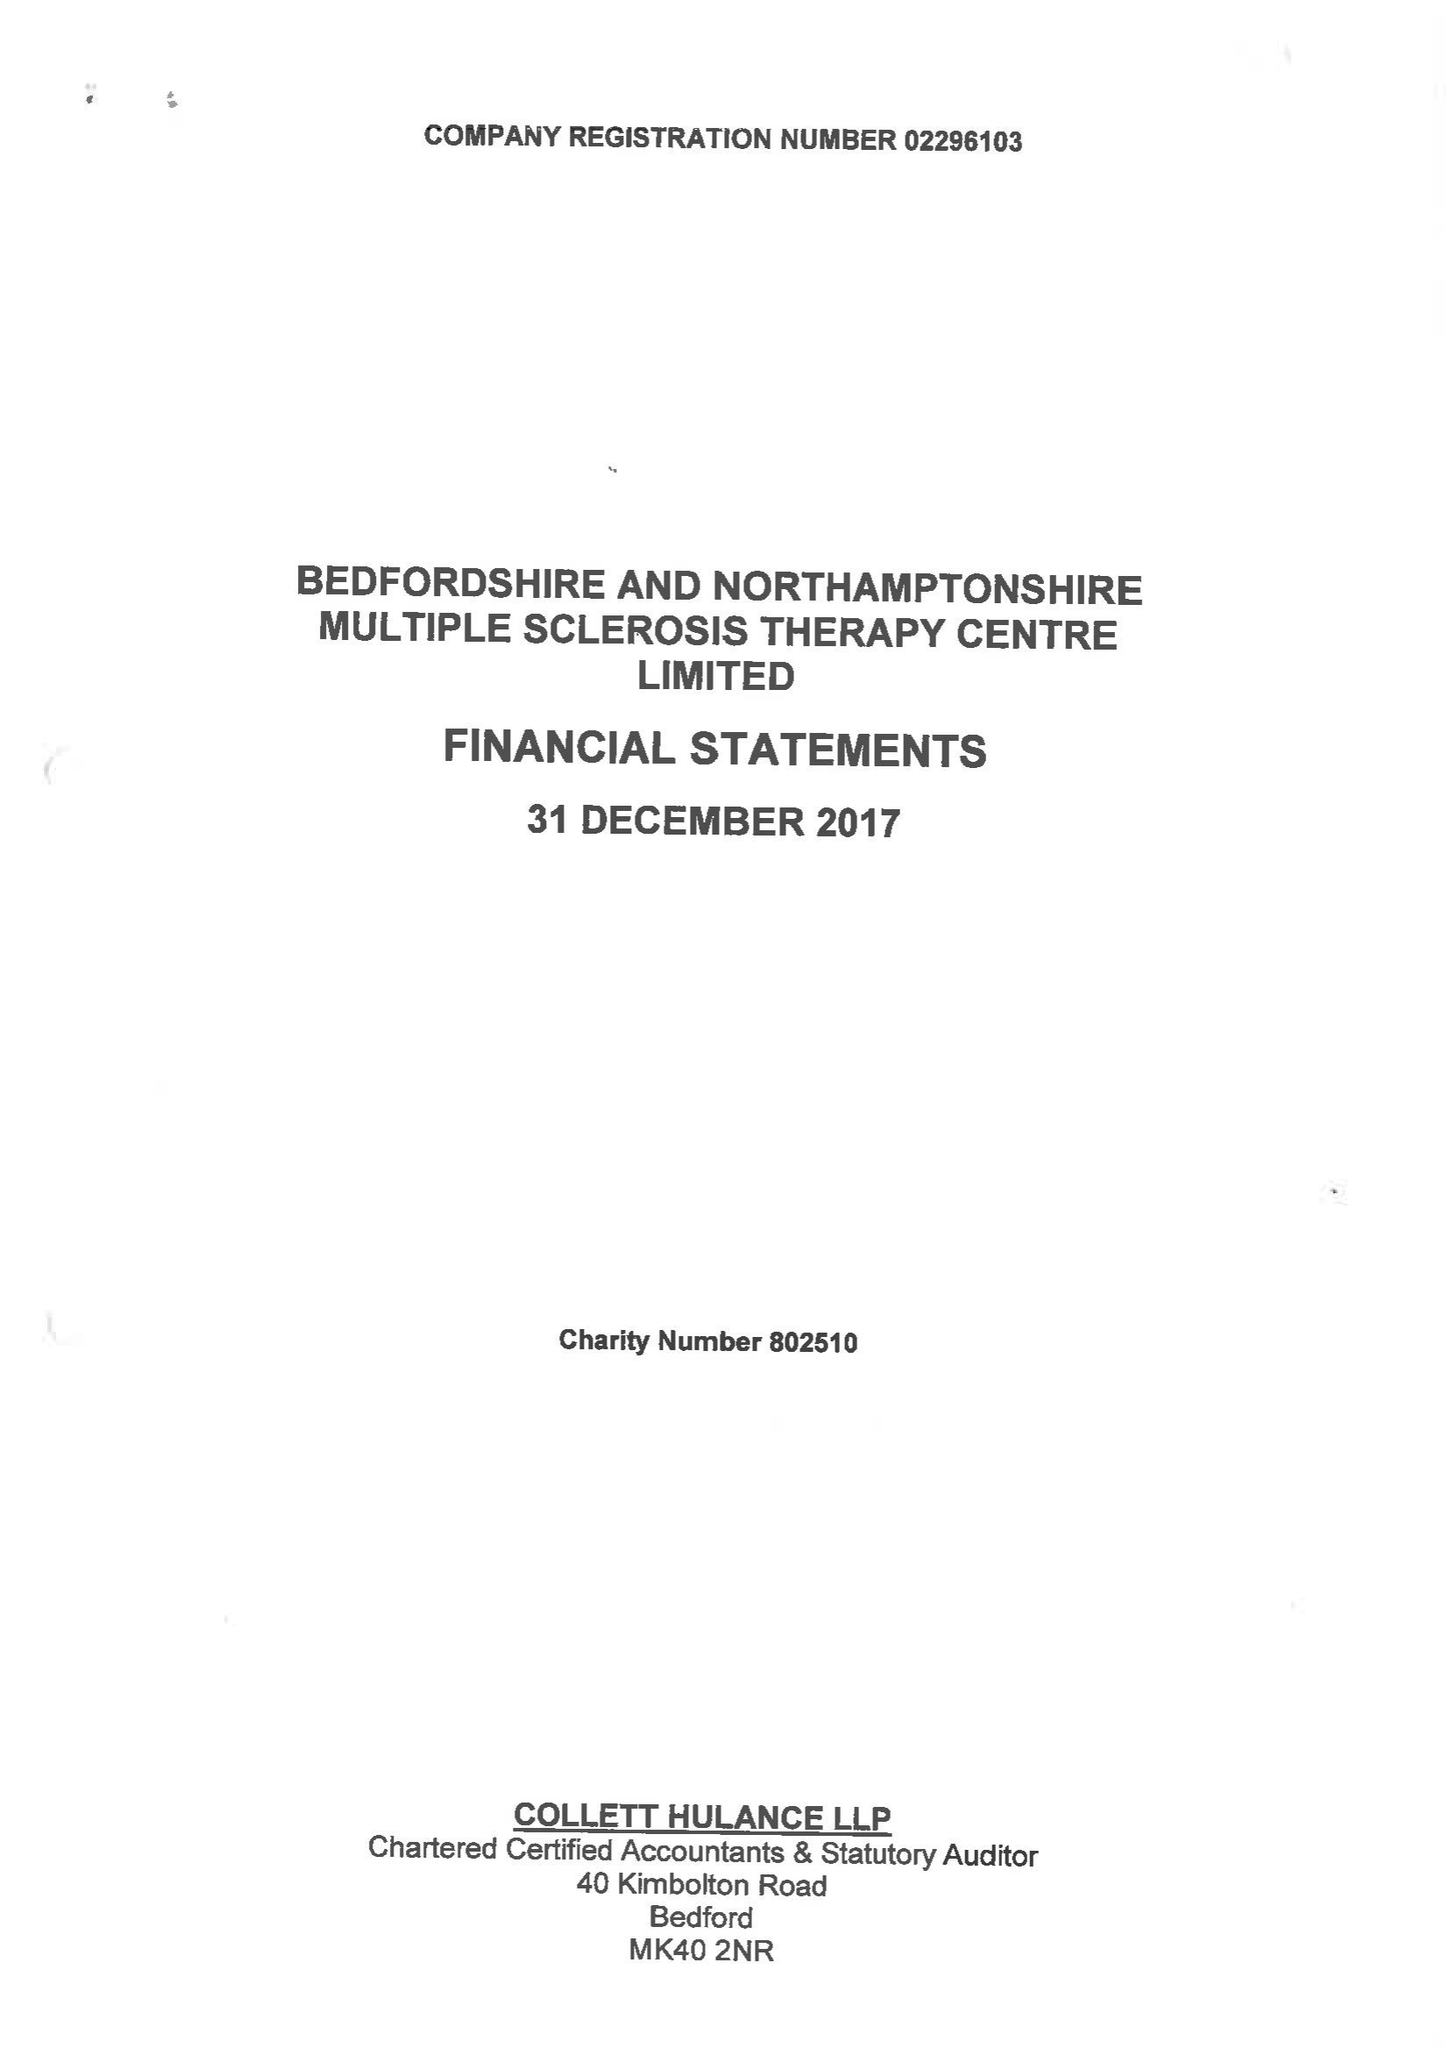What is the value for the address__street_line?
Answer the question using a single word or phrase. BARKERS LANE 